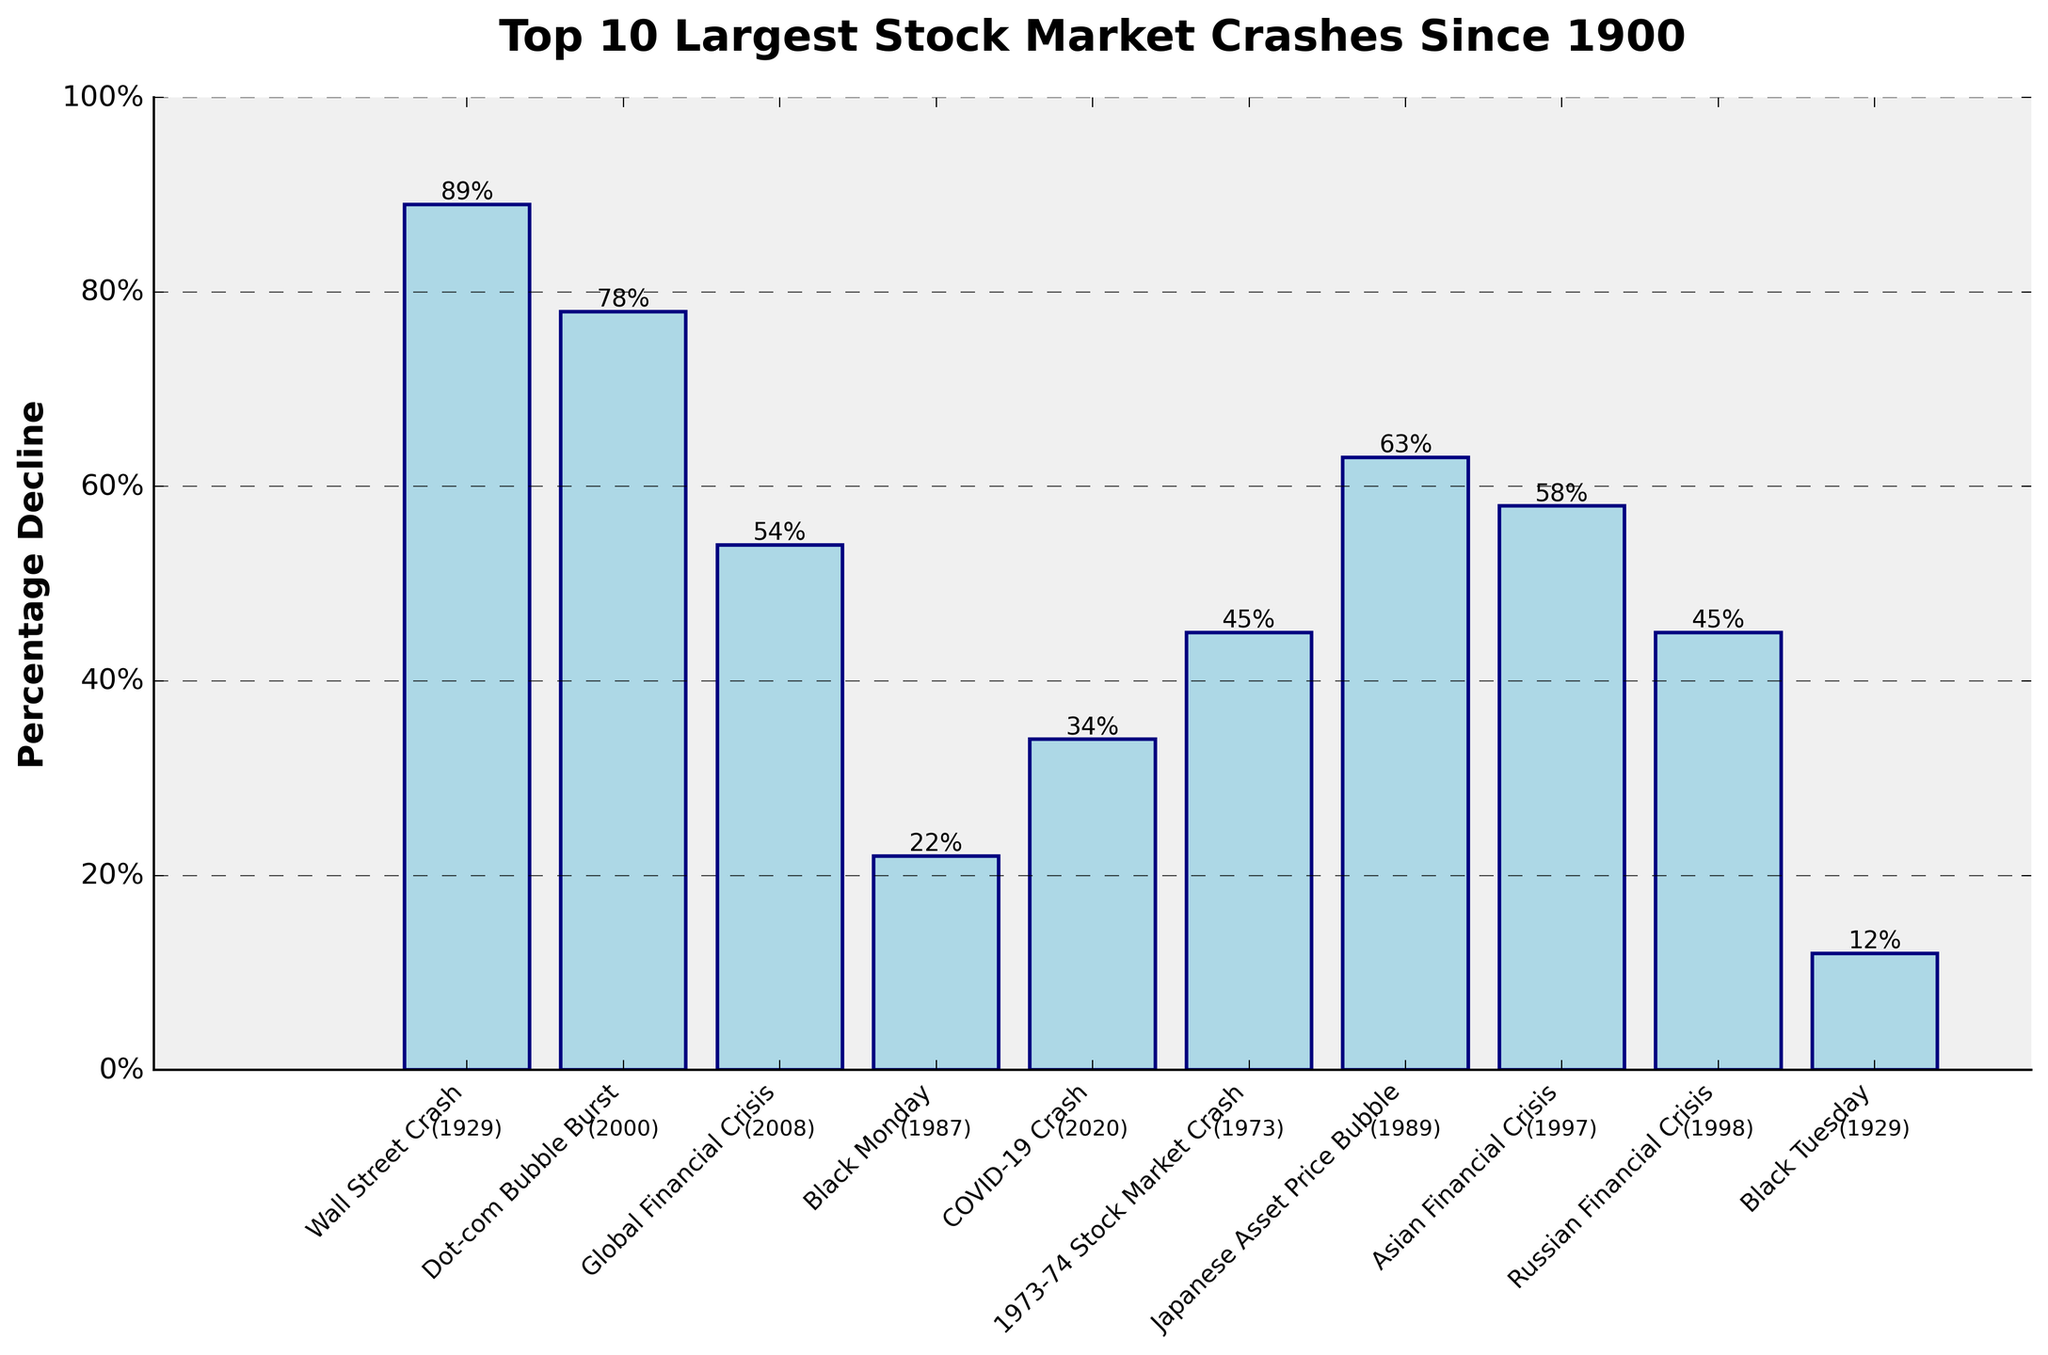What is the total percentage decline of the Wall Street Crash of 1929 and the Dot-com Bubble Burst of 2000? Sum the percentage declines of the Wall Street Crash (89%) and the Dot-com Bubble Burst (78%): 89% + 78% = 167%
Answer: 167% Which stock market crash had the smallest percentage decline, and what was that percentage? Identify the smallest bar in the chart, which corresponds to Black Tuesday with a 12% decline.
Answer: Black Tuesday, 12% By how much did the percentage decline of the Global Financial Crisis in 2008 exceed that of the 1973-74 Stock Market Crash? Subtract the percentage decline of the 1973-74 Stock Market Crash (45%) from that of the Global Financial Crisis (54%): 54% - 45% = 9%
Answer: 9% What is the average percentage decline of the top 3 largest stock market crashes? Identify the top 3 largest crashes (Wall Street Crash, 89%; Dot-com Bubble Burst, 78%; Japanese Asset Price Bubble, 63%), sum their percentage declines, and then divide by 3 (average): (89% + 78% + 63%) / 3 ≈ 76.67%
Answer: 76.67% Which crash occurred more recently, the Asian Financial Crisis or the Russian Financial Crisis, and what are their respective declines? Compare the years of each event (Asian Financial Crisis, 1997; Russian Financial Crisis, 1998). The Russian Financial Crisis occurred later. Their percentage declines were 58% (Asian Financial Crisis) and 45% (Russian Financial Crisis).
Answer: Russian Financial Crisis, 58% and 45% By what percentage is the decline of the COVID-19 Crash lower than the decline of the Japanese Asset Price Bubble? Subtract the percentage decline of the COVID-19 Crash (34%) from that of the Japanese Asset Price Bubble (63%): 63% - 34% = 29%
Answer: 29% Arrange the crashes that occurred in the 21st century by their percentage declines in descending order. Identify the relevant crashes (Dot-com Bubble Burst: 78%, Global Financial Crisis: 54%, COVID-19 Crash: 34%), then arrange them from the highest to the lowest: Dot-com Bubble Burst (78%), Global Financial Crisis (54%), COVID-19 Crash (34%).
Answer: Dot-com Bubble Burst (78%), Global Financial Crisis (54%), COVID-19 Crash (34%) What is the combined percentage decline of the Black Monday crash and Black Tuesday crash? Sum the percentage declines of Black Monday (22%) and Black Tuesday (12%): 22% + 12% = 34%
Answer: 34% Which stock market crash between the years 1997 and 2000 had a higher percentage decline and what were the percentages? Compare the crashes in the specified period: Asian Financial Crisis (1997, 58%) and Dot-com Bubble Burst (2000, 78%). The latter had a higher percentage decline.
Answer: Dot-com Bubble Burst, 78%; Asian Financial Crisis, 58% What is the average percentage decline of all crashes during the 20th century? Identify and sum the percentage declines of all crashes during the 20th century (Wall Street Crash, 89%; Black Monday, 22%; 1973-74 Stock Market Crash, 45%; Japanese Asset Price Bubble, 63%; Asian Financial Crisis, 58%; Russian Financial Crisis, 45%; Black Tuesday, 12%), then divide by the number of crashes: (89% + 22% + 45% + 63% + 58% + 45% + 12%) / 7 ≈ 47.71%
Answer: 47.71% 